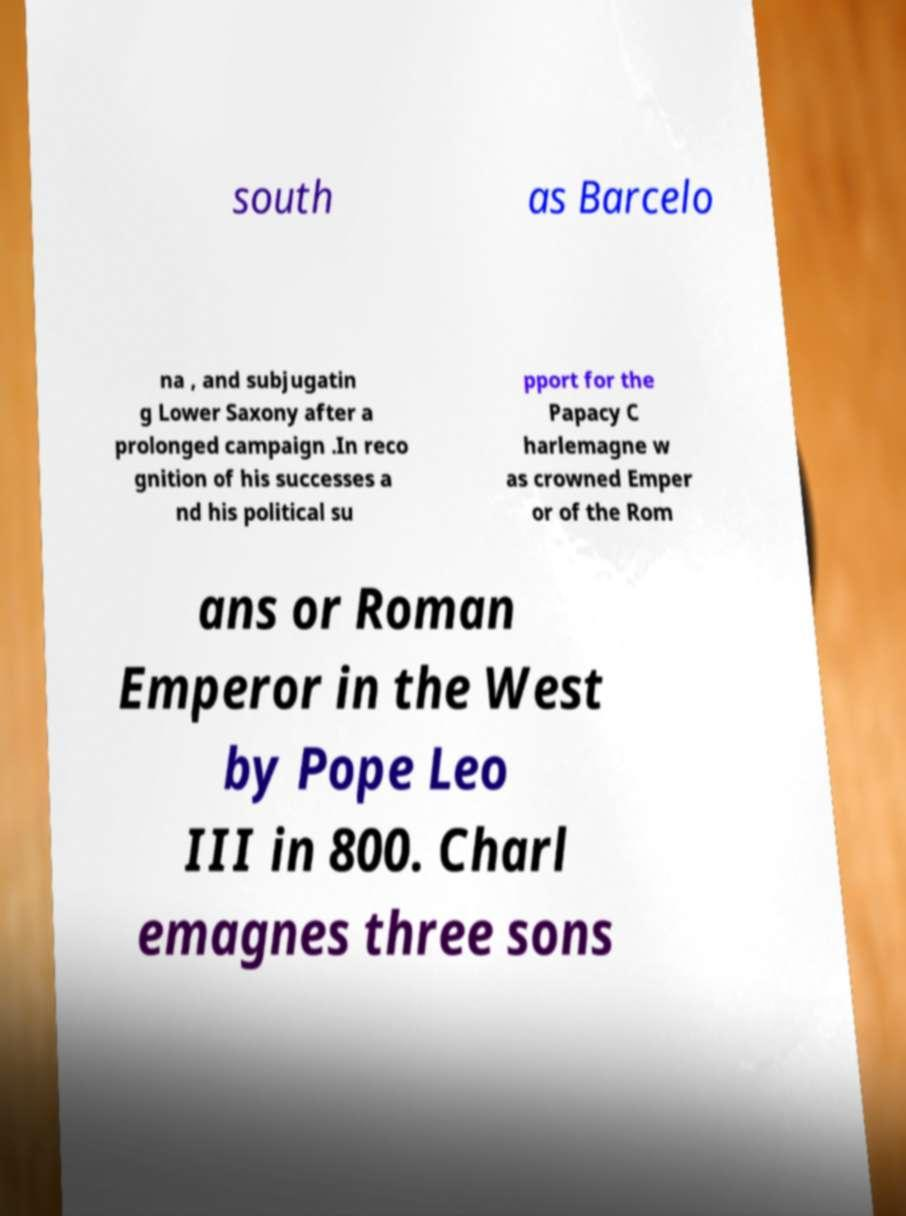Could you assist in decoding the text presented in this image and type it out clearly? south as Barcelo na , and subjugatin g Lower Saxony after a prolonged campaign .In reco gnition of his successes a nd his political su pport for the Papacy C harlemagne w as crowned Emper or of the Rom ans or Roman Emperor in the West by Pope Leo III in 800. Charl emagnes three sons 